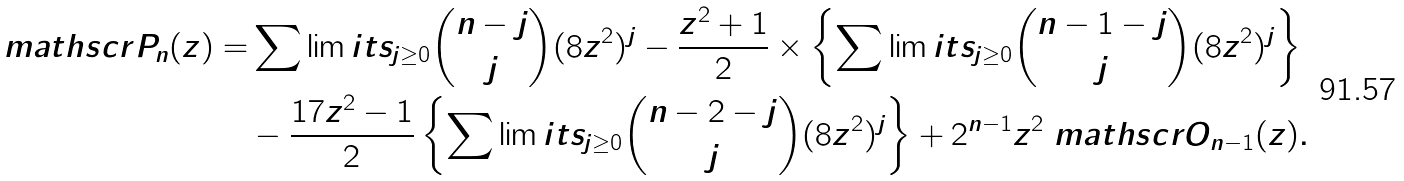<formula> <loc_0><loc_0><loc_500><loc_500>\ m a t h s c r { P } _ { n } ( z ) = & \sum \lim i t s _ { j \geq 0 } \binom { n - j } { j } ( 8 z ^ { 2 } ) ^ { j } - \frac { z ^ { 2 } + 1 } { 2 } \times \left \{ \sum \lim i t s _ { j \geq 0 } \binom { n - 1 - j } { j } ( 8 z ^ { 2 } ) ^ { j } \right \} \\ & - \frac { 1 7 z ^ { 2 } - 1 } { 2 } \left \{ \sum \lim i t s _ { j \geq 0 } \binom { n - 2 - j } { j } ( 8 z ^ { 2 } ) ^ { j } \right \} + 2 ^ { n - 1 } z ^ { 2 } \ m a t h s c r { O } _ { n - 1 } ( z ) .</formula> 